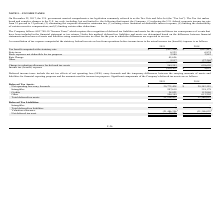According to Telkonet's financial document, When did the U.S. government enact the "Tax Act" ? According to the financial document, December 22, 2017. The relevant text states: "NOTE L – INCOME TAXES On December 22, 2017, the U.S. government enacted comprehensive tax legislation commonly referred to as the Tax Cuts and..." Also, How are deferred tax liabilities and assets determined under ASC 740-10? determined based on the difference between financial statements and tax bases of assets and liabilities using enacted tax rates in effect for the year in which the differences are expected to reverse. The document states: "s method, deferred tax liabilities and assets are determined based on the difference between financial statements and tax bases of assets and liabilit..." Also, What do the income taxes include? net tax effects of net operating loss (NOL) carry forwards and the temporary differences between the carrying amounts of assets and liabilities for financial reporting purposes and the amounts used for income tax purposes. The document states: "Deferred income taxes include the net tax effects of net operating loss (NOL) carry forwards and the temporary differences between the carrying amount..." Also, can you calculate: What is the percentage change in the net operating loss carry forwards from 2018 to 2019? To answer this question, I need to perform calculations using the financial data. The calculation is: (20,772,428-20,342,559)/20,342,559, which equals 2.11 (percentage). This is based on the information: "Net operating loss carry forwards $ 20,772,428 $ 20,342,559 Net operating loss carry forwards $ 20,772,428 $ 20,342,559..." The key data points involved are: 20,342,559, 20,772,428. Also, can you calculate: What is the percentage change in the total deferred tax assets from 2018 to 2019? To answer this question, I need to perform calculations using the financial data. The calculation is: (21,514,417-21,386,025)/21,386,025, which equals 0.6 (percentage). This is based on the information: "Total deferred tax assets 21,514,417 21,386,025 Total deferred tax assets 21,514,417 21,386,025..." The key data points involved are: 21,386,025, 21,514,417. Additionally, Which year has the higher amount of intangibles (deferred tax assets)? According to the financial document, 2018. The relevant text states: "income tax (benefit) /expense is as follows: 2019 2018..." 